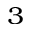<formula> <loc_0><loc_0><loc_500><loc_500>^ { 3 }</formula> 